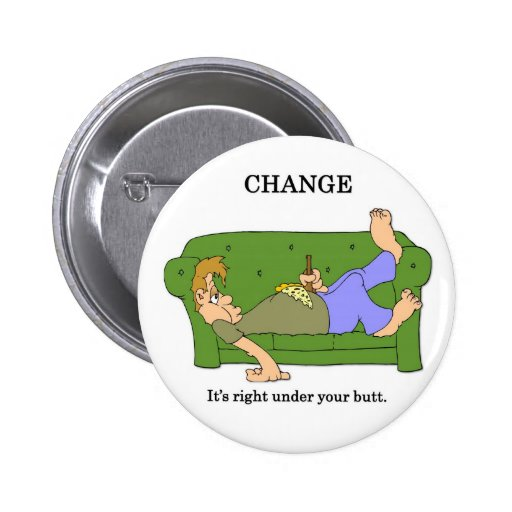Considering the playful nature of the image, how might these characters turn their living room into a fun and engaging environment that promotes creativity and change? The characters could transform their living room into a dynamic 'Creativity Corner' by incorporating flexible workspaces, vibrant colors, and engaging decor that stimulates imagination and productivity. They might include a whiteboard wall for brainstorming sessions, a cozy reading nook, and a variety of art supplies readily accessible. Additionally, they could organize themed nights—such as 'Innovation Fridays' where they tackle a new creative challenge together, or invite friends over for collaborative projects. By making their living space a hub of inspiration and activity, they foster a culture of ongoing creative engagement and positive change. 